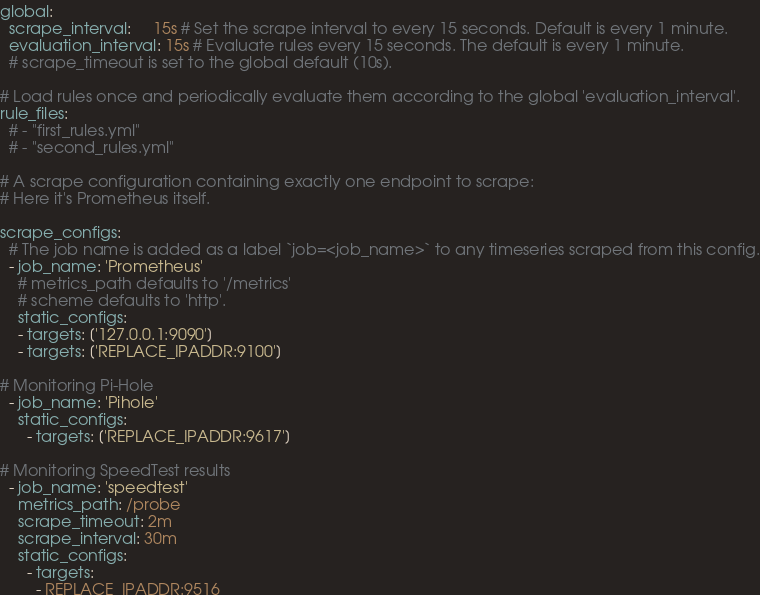Convert code to text. <code><loc_0><loc_0><loc_500><loc_500><_YAML_>global:
  scrape_interval:     15s # Set the scrape interval to every 15 seconds. Default is every 1 minute.
  evaluation_interval: 15s # Evaluate rules every 15 seconds. The default is every 1 minute.
  # scrape_timeout is set to the global default (10s).

# Load rules once and periodically evaluate them according to the global 'evaluation_interval'.
rule_files:
  # - "first_rules.yml"
  # - "second_rules.yml"

# A scrape configuration containing exactly one endpoint to scrape:
# Here it's Prometheus itself.

scrape_configs:
  # The job name is added as a label `job=<job_name>` to any timeseries scraped from this config.
  - job_name: 'Prometheus'
    # metrics_path defaults to '/metrics'
    # scheme defaults to 'http'.
    static_configs:
    - targets: ['127.0.0.1:9090']
    - targets: ['REPLACE_IPADDR:9100']

# Monitoring Pi-Hole
  - job_name: 'Pihole'
    static_configs:
      - targets: ['REPLACE_IPADDR:9617']

# Monitoring SpeedTest results
  - job_name: 'speedtest'
    metrics_path: /probe
    scrape_timeout: 2m
    scrape_interval: 30m
    static_configs:
      - targets:
        - REPLACE_IPADDR:9516
</code> 